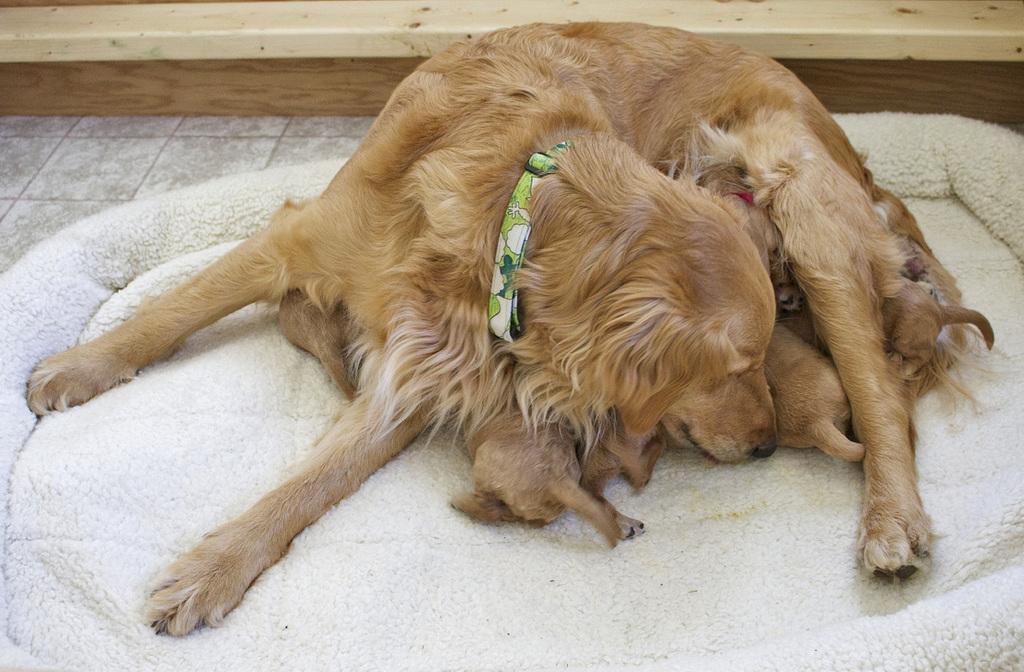Could you give a brief overview of what you see in this image? In this picture we can see a dog and puppies here, at the bottom there is a mat, we can see a strap on dog´s neck. 